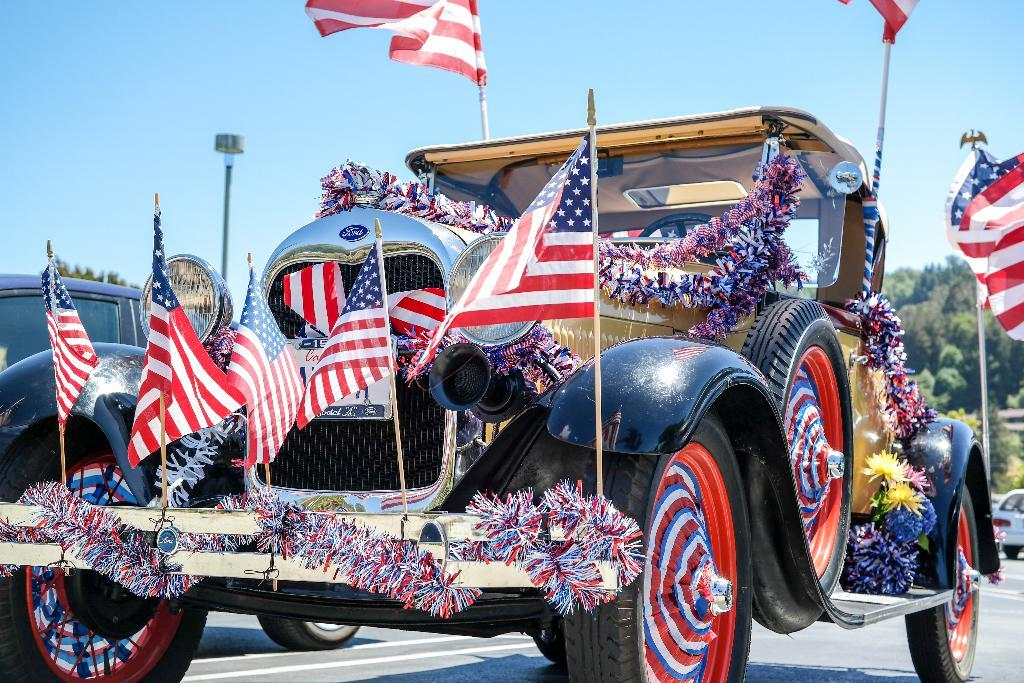What types of objects are in the image? There are vehicles in the image. What distinguishes some of the vehicles? Flags are attached to at least one vehicle, and decorative ribbon is present on at least one vehicle. What can be seen in the background of the image? There are trees and the sky visible in the background of the image. What type of detail can be seen on the rat in the image? There is no rat present in the image, so it is not possible to answer that question. 